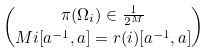Convert formula to latex. <formula><loc_0><loc_0><loc_500><loc_500>\pi ( \Omega _ { i } ) \in \frac { 1 } { 2 ^ { M } } \choose { M } { i } [ a ^ { - 1 } , a ] = r ( i ) [ a ^ { - 1 } , a ]</formula> 